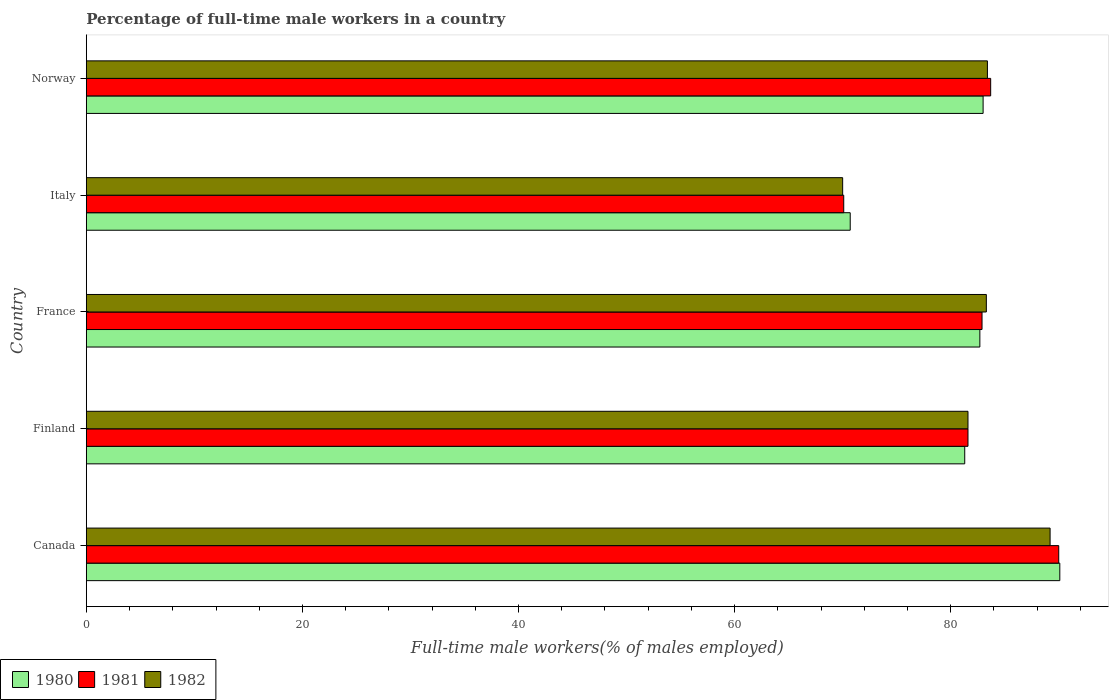How many different coloured bars are there?
Give a very brief answer. 3. How many groups of bars are there?
Give a very brief answer. 5. What is the label of the 5th group of bars from the top?
Your answer should be compact. Canada. In how many cases, is the number of bars for a given country not equal to the number of legend labels?
Your answer should be compact. 0. What is the percentage of full-time male workers in 1980 in Finland?
Your answer should be compact. 81.3. Across all countries, what is the maximum percentage of full-time male workers in 1982?
Keep it short and to the point. 89.2. Across all countries, what is the minimum percentage of full-time male workers in 1981?
Offer a very short reply. 70.1. What is the total percentage of full-time male workers in 1982 in the graph?
Provide a short and direct response. 407.5. What is the difference between the percentage of full-time male workers in 1981 in Canada and that in Italy?
Give a very brief answer. 19.9. What is the average percentage of full-time male workers in 1981 per country?
Your answer should be very brief. 81.66. What is the difference between the percentage of full-time male workers in 1980 and percentage of full-time male workers in 1981 in Norway?
Ensure brevity in your answer.  -0.7. What is the ratio of the percentage of full-time male workers in 1980 in Canada to that in Italy?
Keep it short and to the point. 1.27. Is the percentage of full-time male workers in 1980 in Canada less than that in Norway?
Provide a succinct answer. No. What is the difference between the highest and the second highest percentage of full-time male workers in 1982?
Make the answer very short. 5.8. What is the difference between the highest and the lowest percentage of full-time male workers in 1980?
Make the answer very short. 19.4. In how many countries, is the percentage of full-time male workers in 1980 greater than the average percentage of full-time male workers in 1980 taken over all countries?
Keep it short and to the point. 3. Is the sum of the percentage of full-time male workers in 1980 in France and Norway greater than the maximum percentage of full-time male workers in 1981 across all countries?
Keep it short and to the point. Yes. What does the 1st bar from the top in Finland represents?
Give a very brief answer. 1982. What does the 2nd bar from the bottom in France represents?
Offer a terse response. 1981. How many bars are there?
Your answer should be compact. 15. How many countries are there in the graph?
Keep it short and to the point. 5. How many legend labels are there?
Make the answer very short. 3. What is the title of the graph?
Ensure brevity in your answer.  Percentage of full-time male workers in a country. What is the label or title of the X-axis?
Offer a terse response. Full-time male workers(% of males employed). What is the label or title of the Y-axis?
Your response must be concise. Country. What is the Full-time male workers(% of males employed) in 1980 in Canada?
Keep it short and to the point. 90.1. What is the Full-time male workers(% of males employed) of 1982 in Canada?
Offer a terse response. 89.2. What is the Full-time male workers(% of males employed) in 1980 in Finland?
Give a very brief answer. 81.3. What is the Full-time male workers(% of males employed) of 1981 in Finland?
Offer a terse response. 81.6. What is the Full-time male workers(% of males employed) in 1982 in Finland?
Provide a short and direct response. 81.6. What is the Full-time male workers(% of males employed) of 1980 in France?
Provide a succinct answer. 82.7. What is the Full-time male workers(% of males employed) in 1981 in France?
Your answer should be compact. 82.9. What is the Full-time male workers(% of males employed) of 1982 in France?
Ensure brevity in your answer.  83.3. What is the Full-time male workers(% of males employed) of 1980 in Italy?
Your answer should be very brief. 70.7. What is the Full-time male workers(% of males employed) in 1981 in Italy?
Provide a short and direct response. 70.1. What is the Full-time male workers(% of males employed) in 1982 in Italy?
Keep it short and to the point. 70. What is the Full-time male workers(% of males employed) in 1980 in Norway?
Provide a succinct answer. 83. What is the Full-time male workers(% of males employed) in 1981 in Norway?
Provide a succinct answer. 83.7. What is the Full-time male workers(% of males employed) in 1982 in Norway?
Provide a short and direct response. 83.4. Across all countries, what is the maximum Full-time male workers(% of males employed) of 1980?
Give a very brief answer. 90.1. Across all countries, what is the maximum Full-time male workers(% of males employed) of 1981?
Offer a terse response. 90. Across all countries, what is the maximum Full-time male workers(% of males employed) in 1982?
Keep it short and to the point. 89.2. Across all countries, what is the minimum Full-time male workers(% of males employed) in 1980?
Keep it short and to the point. 70.7. Across all countries, what is the minimum Full-time male workers(% of males employed) of 1981?
Make the answer very short. 70.1. Across all countries, what is the minimum Full-time male workers(% of males employed) of 1982?
Your answer should be very brief. 70. What is the total Full-time male workers(% of males employed) of 1980 in the graph?
Provide a short and direct response. 407.8. What is the total Full-time male workers(% of males employed) in 1981 in the graph?
Your response must be concise. 408.3. What is the total Full-time male workers(% of males employed) of 1982 in the graph?
Give a very brief answer. 407.5. What is the difference between the Full-time male workers(% of males employed) of 1980 in Canada and that in Finland?
Your answer should be very brief. 8.8. What is the difference between the Full-time male workers(% of males employed) of 1981 in Canada and that in France?
Make the answer very short. 7.1. What is the difference between the Full-time male workers(% of males employed) of 1982 in Canada and that in Italy?
Offer a very short reply. 19.2. What is the difference between the Full-time male workers(% of males employed) of 1981 in Canada and that in Norway?
Your answer should be very brief. 6.3. What is the difference between the Full-time male workers(% of males employed) in 1982 in Canada and that in Norway?
Offer a very short reply. 5.8. What is the difference between the Full-time male workers(% of males employed) in 1981 in Finland and that in France?
Give a very brief answer. -1.3. What is the difference between the Full-time male workers(% of males employed) in 1982 in Finland and that in France?
Offer a very short reply. -1.7. What is the difference between the Full-time male workers(% of males employed) in 1980 in Finland and that in Italy?
Provide a short and direct response. 10.6. What is the difference between the Full-time male workers(% of males employed) in 1981 in Finland and that in Italy?
Your answer should be very brief. 11.5. What is the difference between the Full-time male workers(% of males employed) in 1981 in Finland and that in Norway?
Ensure brevity in your answer.  -2.1. What is the difference between the Full-time male workers(% of males employed) in 1980 in France and that in Italy?
Provide a short and direct response. 12. What is the difference between the Full-time male workers(% of males employed) in 1981 in France and that in Italy?
Make the answer very short. 12.8. What is the difference between the Full-time male workers(% of males employed) of 1982 in France and that in Italy?
Make the answer very short. 13.3. What is the difference between the Full-time male workers(% of males employed) of 1980 in France and that in Norway?
Provide a succinct answer. -0.3. What is the difference between the Full-time male workers(% of males employed) of 1981 in France and that in Norway?
Your response must be concise. -0.8. What is the difference between the Full-time male workers(% of males employed) of 1981 in Italy and that in Norway?
Your response must be concise. -13.6. What is the difference between the Full-time male workers(% of males employed) of 1982 in Italy and that in Norway?
Your answer should be compact. -13.4. What is the difference between the Full-time male workers(% of males employed) of 1980 in Canada and the Full-time male workers(% of males employed) of 1981 in Finland?
Give a very brief answer. 8.5. What is the difference between the Full-time male workers(% of males employed) in 1980 in Canada and the Full-time male workers(% of males employed) in 1982 in Finland?
Your response must be concise. 8.5. What is the difference between the Full-time male workers(% of males employed) of 1980 in Canada and the Full-time male workers(% of males employed) of 1982 in France?
Make the answer very short. 6.8. What is the difference between the Full-time male workers(% of males employed) in 1981 in Canada and the Full-time male workers(% of males employed) in 1982 in France?
Your answer should be compact. 6.7. What is the difference between the Full-time male workers(% of males employed) in 1980 in Canada and the Full-time male workers(% of males employed) in 1982 in Italy?
Your answer should be very brief. 20.1. What is the difference between the Full-time male workers(% of males employed) of 1981 in Canada and the Full-time male workers(% of males employed) of 1982 in Norway?
Your answer should be very brief. 6.6. What is the difference between the Full-time male workers(% of males employed) of 1980 in Finland and the Full-time male workers(% of males employed) of 1981 in Italy?
Offer a terse response. 11.2. What is the difference between the Full-time male workers(% of males employed) of 1980 in Finland and the Full-time male workers(% of males employed) of 1982 in Italy?
Ensure brevity in your answer.  11.3. What is the difference between the Full-time male workers(% of males employed) in 1980 in Finland and the Full-time male workers(% of males employed) in 1981 in Norway?
Give a very brief answer. -2.4. What is the difference between the Full-time male workers(% of males employed) of 1980 in Finland and the Full-time male workers(% of males employed) of 1982 in Norway?
Provide a succinct answer. -2.1. What is the difference between the Full-time male workers(% of males employed) of 1980 in Italy and the Full-time male workers(% of males employed) of 1982 in Norway?
Offer a terse response. -12.7. What is the difference between the Full-time male workers(% of males employed) of 1981 in Italy and the Full-time male workers(% of males employed) of 1982 in Norway?
Your response must be concise. -13.3. What is the average Full-time male workers(% of males employed) in 1980 per country?
Make the answer very short. 81.56. What is the average Full-time male workers(% of males employed) of 1981 per country?
Your answer should be very brief. 81.66. What is the average Full-time male workers(% of males employed) in 1982 per country?
Keep it short and to the point. 81.5. What is the difference between the Full-time male workers(% of males employed) in 1980 and Full-time male workers(% of males employed) in 1982 in Finland?
Offer a very short reply. -0.3. What is the difference between the Full-time male workers(% of males employed) of 1980 and Full-time male workers(% of males employed) of 1981 in France?
Provide a succinct answer. -0.2. What is the difference between the Full-time male workers(% of males employed) in 1980 and Full-time male workers(% of males employed) in 1982 in France?
Ensure brevity in your answer.  -0.6. What is the difference between the Full-time male workers(% of males employed) in 1980 and Full-time male workers(% of males employed) in 1981 in Italy?
Your response must be concise. 0.6. What is the difference between the Full-time male workers(% of males employed) in 1981 and Full-time male workers(% of males employed) in 1982 in Italy?
Make the answer very short. 0.1. What is the difference between the Full-time male workers(% of males employed) in 1980 and Full-time male workers(% of males employed) in 1981 in Norway?
Keep it short and to the point. -0.7. What is the difference between the Full-time male workers(% of males employed) of 1981 and Full-time male workers(% of males employed) of 1982 in Norway?
Your answer should be compact. 0.3. What is the ratio of the Full-time male workers(% of males employed) of 1980 in Canada to that in Finland?
Offer a very short reply. 1.11. What is the ratio of the Full-time male workers(% of males employed) of 1981 in Canada to that in Finland?
Your response must be concise. 1.1. What is the ratio of the Full-time male workers(% of males employed) in 1982 in Canada to that in Finland?
Keep it short and to the point. 1.09. What is the ratio of the Full-time male workers(% of males employed) of 1980 in Canada to that in France?
Offer a terse response. 1.09. What is the ratio of the Full-time male workers(% of males employed) of 1981 in Canada to that in France?
Give a very brief answer. 1.09. What is the ratio of the Full-time male workers(% of males employed) in 1982 in Canada to that in France?
Your answer should be very brief. 1.07. What is the ratio of the Full-time male workers(% of males employed) in 1980 in Canada to that in Italy?
Offer a very short reply. 1.27. What is the ratio of the Full-time male workers(% of males employed) in 1981 in Canada to that in Italy?
Ensure brevity in your answer.  1.28. What is the ratio of the Full-time male workers(% of males employed) in 1982 in Canada to that in Italy?
Your response must be concise. 1.27. What is the ratio of the Full-time male workers(% of males employed) of 1980 in Canada to that in Norway?
Ensure brevity in your answer.  1.09. What is the ratio of the Full-time male workers(% of males employed) of 1981 in Canada to that in Norway?
Provide a succinct answer. 1.08. What is the ratio of the Full-time male workers(% of males employed) in 1982 in Canada to that in Norway?
Offer a terse response. 1.07. What is the ratio of the Full-time male workers(% of males employed) in 1980 in Finland to that in France?
Provide a succinct answer. 0.98. What is the ratio of the Full-time male workers(% of males employed) in 1981 in Finland to that in France?
Your response must be concise. 0.98. What is the ratio of the Full-time male workers(% of males employed) of 1982 in Finland to that in France?
Make the answer very short. 0.98. What is the ratio of the Full-time male workers(% of males employed) in 1980 in Finland to that in Italy?
Give a very brief answer. 1.15. What is the ratio of the Full-time male workers(% of males employed) of 1981 in Finland to that in Italy?
Your answer should be compact. 1.16. What is the ratio of the Full-time male workers(% of males employed) in 1982 in Finland to that in Italy?
Provide a succinct answer. 1.17. What is the ratio of the Full-time male workers(% of males employed) in 1980 in Finland to that in Norway?
Offer a very short reply. 0.98. What is the ratio of the Full-time male workers(% of males employed) in 1981 in Finland to that in Norway?
Offer a terse response. 0.97. What is the ratio of the Full-time male workers(% of males employed) of 1982 in Finland to that in Norway?
Your answer should be compact. 0.98. What is the ratio of the Full-time male workers(% of males employed) of 1980 in France to that in Italy?
Your answer should be compact. 1.17. What is the ratio of the Full-time male workers(% of males employed) in 1981 in France to that in Italy?
Your response must be concise. 1.18. What is the ratio of the Full-time male workers(% of males employed) of 1982 in France to that in Italy?
Provide a succinct answer. 1.19. What is the ratio of the Full-time male workers(% of males employed) in 1982 in France to that in Norway?
Your answer should be very brief. 1. What is the ratio of the Full-time male workers(% of males employed) of 1980 in Italy to that in Norway?
Provide a short and direct response. 0.85. What is the ratio of the Full-time male workers(% of males employed) of 1981 in Italy to that in Norway?
Make the answer very short. 0.84. What is the ratio of the Full-time male workers(% of males employed) in 1982 in Italy to that in Norway?
Your answer should be very brief. 0.84. What is the difference between the highest and the second highest Full-time male workers(% of males employed) in 1980?
Give a very brief answer. 7.1. What is the difference between the highest and the second highest Full-time male workers(% of males employed) in 1981?
Make the answer very short. 6.3. What is the difference between the highest and the second highest Full-time male workers(% of males employed) in 1982?
Give a very brief answer. 5.8. What is the difference between the highest and the lowest Full-time male workers(% of males employed) of 1981?
Offer a terse response. 19.9. What is the difference between the highest and the lowest Full-time male workers(% of males employed) of 1982?
Offer a very short reply. 19.2. 